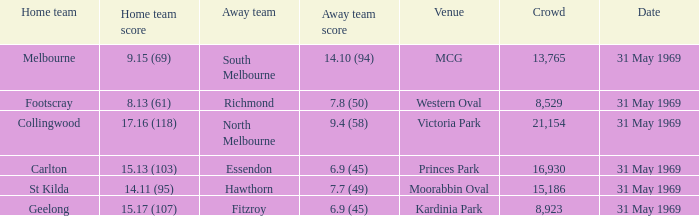17 (107), who was the visiting team? Fitzroy. 